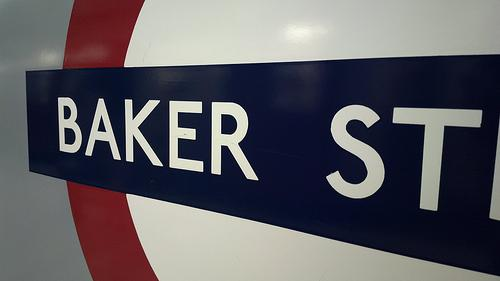Describe the shape and appearance of the company logo. The company logo is a circle with a red, white and blue design, featuring a blue stripe with white text on a white background bordered by a red circle. Perform an image sentiment analysis and determine the feeling this image might evoke. The image may evoke feelings of familiarity or navigational guidance, as it displays a street sign which is used for direction. Assess the image quality by mentioning the light reflection and any parts that might be cut off. The image quality is affected by light reflection in certain areas, causing some glare spots. Additionally, one white letter on the sign and some letters on the right margin are partially cut off. Identify the main colors present in the image. The main colors in the image are blue, white, grey, and red. Count the number of white letters visible on the sign. There are 7 white letters visible on the sign. In the object interaction analysis task, describe the relationship between the red circle and the blue stripe on the sign. The red circle borders the white circle containing the blue stripe, establishing a visual hierarchy and contrast in the design of the sign. What does the text on the sign display? The text on the sign says "Baker St" in white capital letters. For the VQA task, determine if the sign is most likely a street sign or a station sign. The sign is most likely a street sign. What is the layout and structure of the sign? The sign has a grey-colored background with a white circle that is bordered by a red circle. Inside the white circle, there is a long blue rectangle with the text "Baker St" in white capital letters. How many light glare spots are there in the image? There are 5 light glare spots in the image. Mention the colors of the surfaces that constitute the body of the sign. The surfaces are colored white, blue, and red. What parts of the image show partial representation? Part of a letter cut off and a partial red circle on a white background. Analyze the extent of the light glare within the image. The light glare appears on the sign, the gray, and the red part, with dashed light reflected over the navy rectangle. Describe the overall design of this company logo. The logo has a grey background with a blue and white street sign, featuring blue, red, and white elements, and white text that says "Baker St". Identify the hidden pink swirl underneath the white letters. How would you describe its pattern?  No, it's not mentioned in the image. Which of the following describes the sign's shape? A) Square B) Rectangle C) Circle D) Oval B) Rectangle What can one infer about the location of the sign? It may represent Baker Street or Baker Station. What two-letter combination can be seen in white lettering within the image? "ST" What colors are mostly featured on this sign? Blue, white, and red. Identify and specify the color of the circle bordering the white circle. The bordering circle is red. What color is the stripe on the white background? Blue Summarize the layout of the letters within the image. The letters are white, appearing on a blue background with "Baker" on one side and "St" on the other side, partially extending past the photo's margin. Which letters appear in white on a blue background? Baker St Does the main body of the sign look circular or rectangular? Circular What is the implied text cut off from the photo's margin? "Baker St" Describe the interaction between the reflected light and the navy rectangle. The dashed light is reflected over the navy rectangle, with slight bleed into it. Is the gray background part of the sign or a separate element in the image? Separate element. What elements within the image display light glare? Light glare on the sign, gray, and red part. 